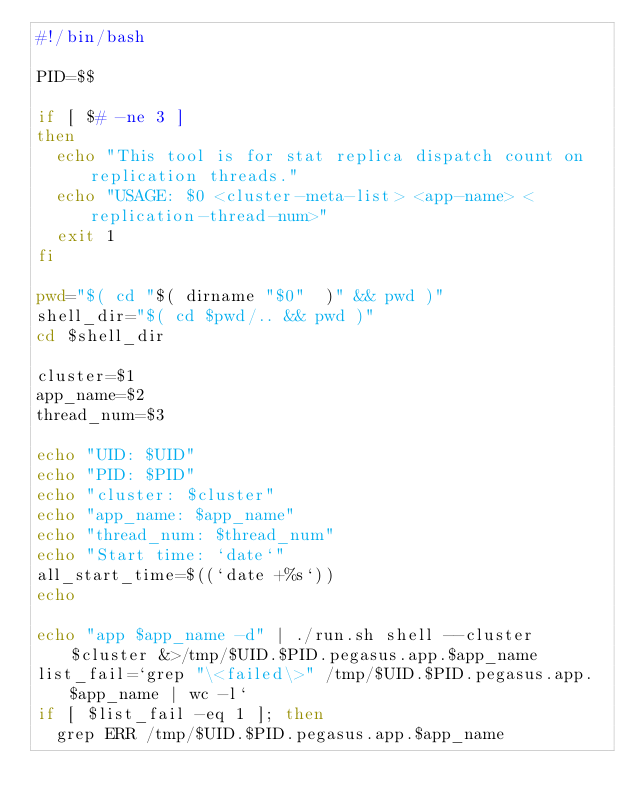<code> <loc_0><loc_0><loc_500><loc_500><_Bash_>#!/bin/bash

PID=$$

if [ $# -ne 3 ]
then
  echo "This tool is for stat replica dispatch count on replication threads."
  echo "USAGE: $0 <cluster-meta-list> <app-name> <replication-thread-num>"
  exit 1
fi

pwd="$( cd "$( dirname "$0"  )" && pwd )"
shell_dir="$( cd $pwd/.. && pwd )"
cd $shell_dir

cluster=$1
app_name=$2
thread_num=$3

echo "UID: $UID"
echo "PID: $PID"
echo "cluster: $cluster"
echo "app_name: $app_name"
echo "thread_num: $thread_num"
echo "Start time: `date`"
all_start_time=$((`date +%s`))
echo

echo "app $app_name -d" | ./run.sh shell --cluster $cluster &>/tmp/$UID.$PID.pegasus.app.$app_name
list_fail=`grep "\<failed\>" /tmp/$UID.$PID.pegasus.app.$app_name | wc -l`
if [ $list_fail -eq 1 ]; then
  grep ERR /tmp/$UID.$PID.pegasus.app.$app_name</code> 